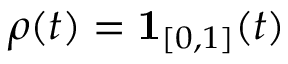Convert formula to latex. <formula><loc_0><loc_0><loc_500><loc_500>\rho ( t ) = \mathbf 1 _ { [ 0 , 1 ] } ( t )</formula> 